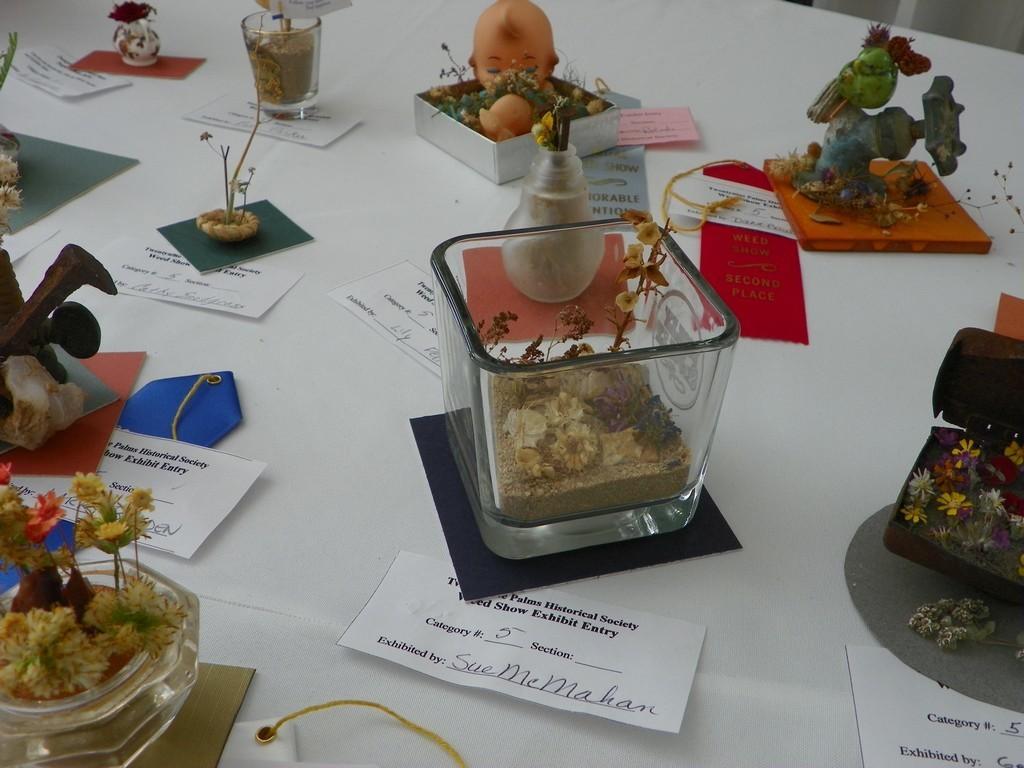Can you describe this image briefly? On a white surface we can see planets, toy, containers and other objects. Here we can see paper notes. 